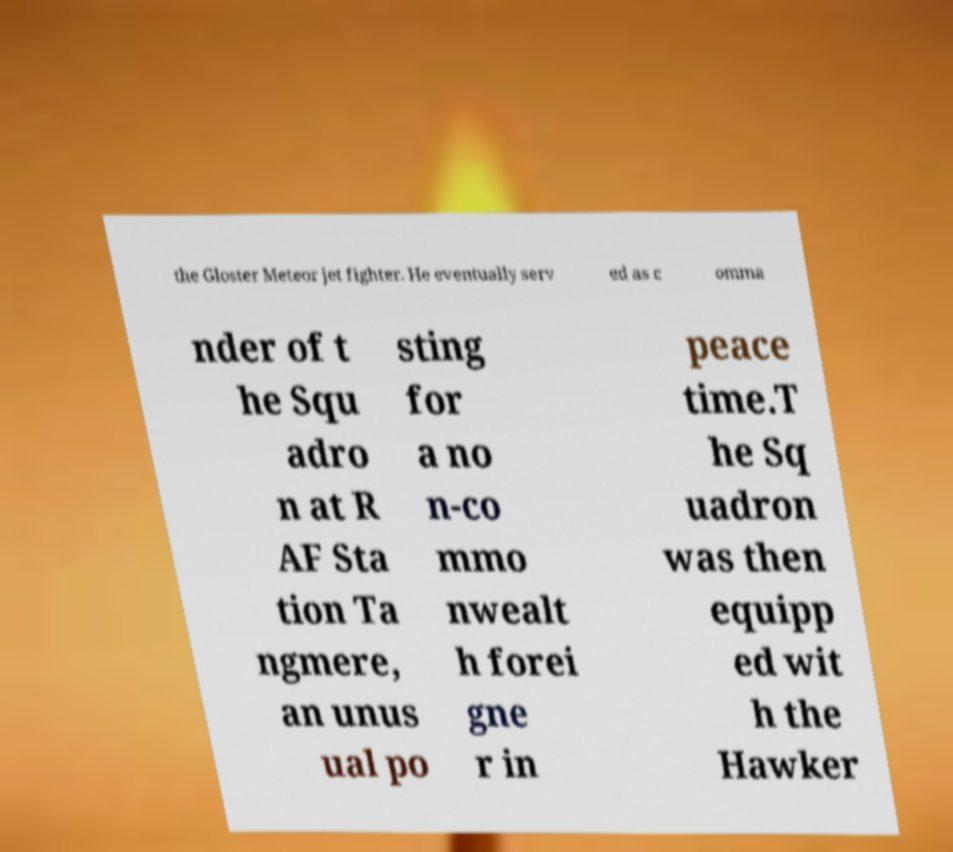Could you extract and type out the text from this image? the Gloster Meteor jet fighter. He eventually serv ed as c omma nder of t he Squ adro n at R AF Sta tion Ta ngmere, an unus ual po sting for a no n-co mmo nwealt h forei gne r in peace time.T he Sq uadron was then equipp ed wit h the Hawker 